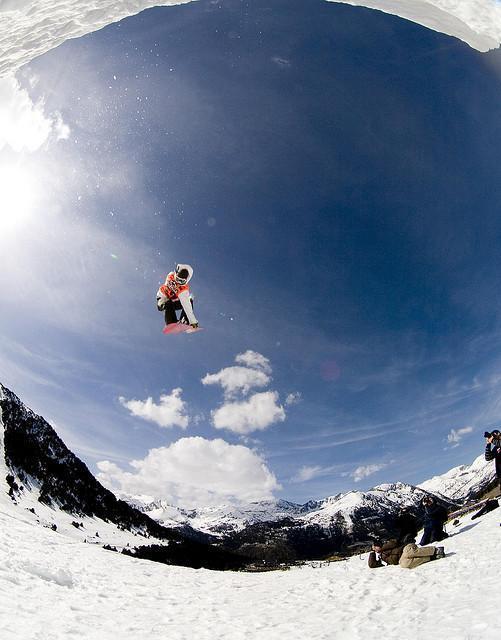How many people are in this image?
Give a very brief answer. 4. 